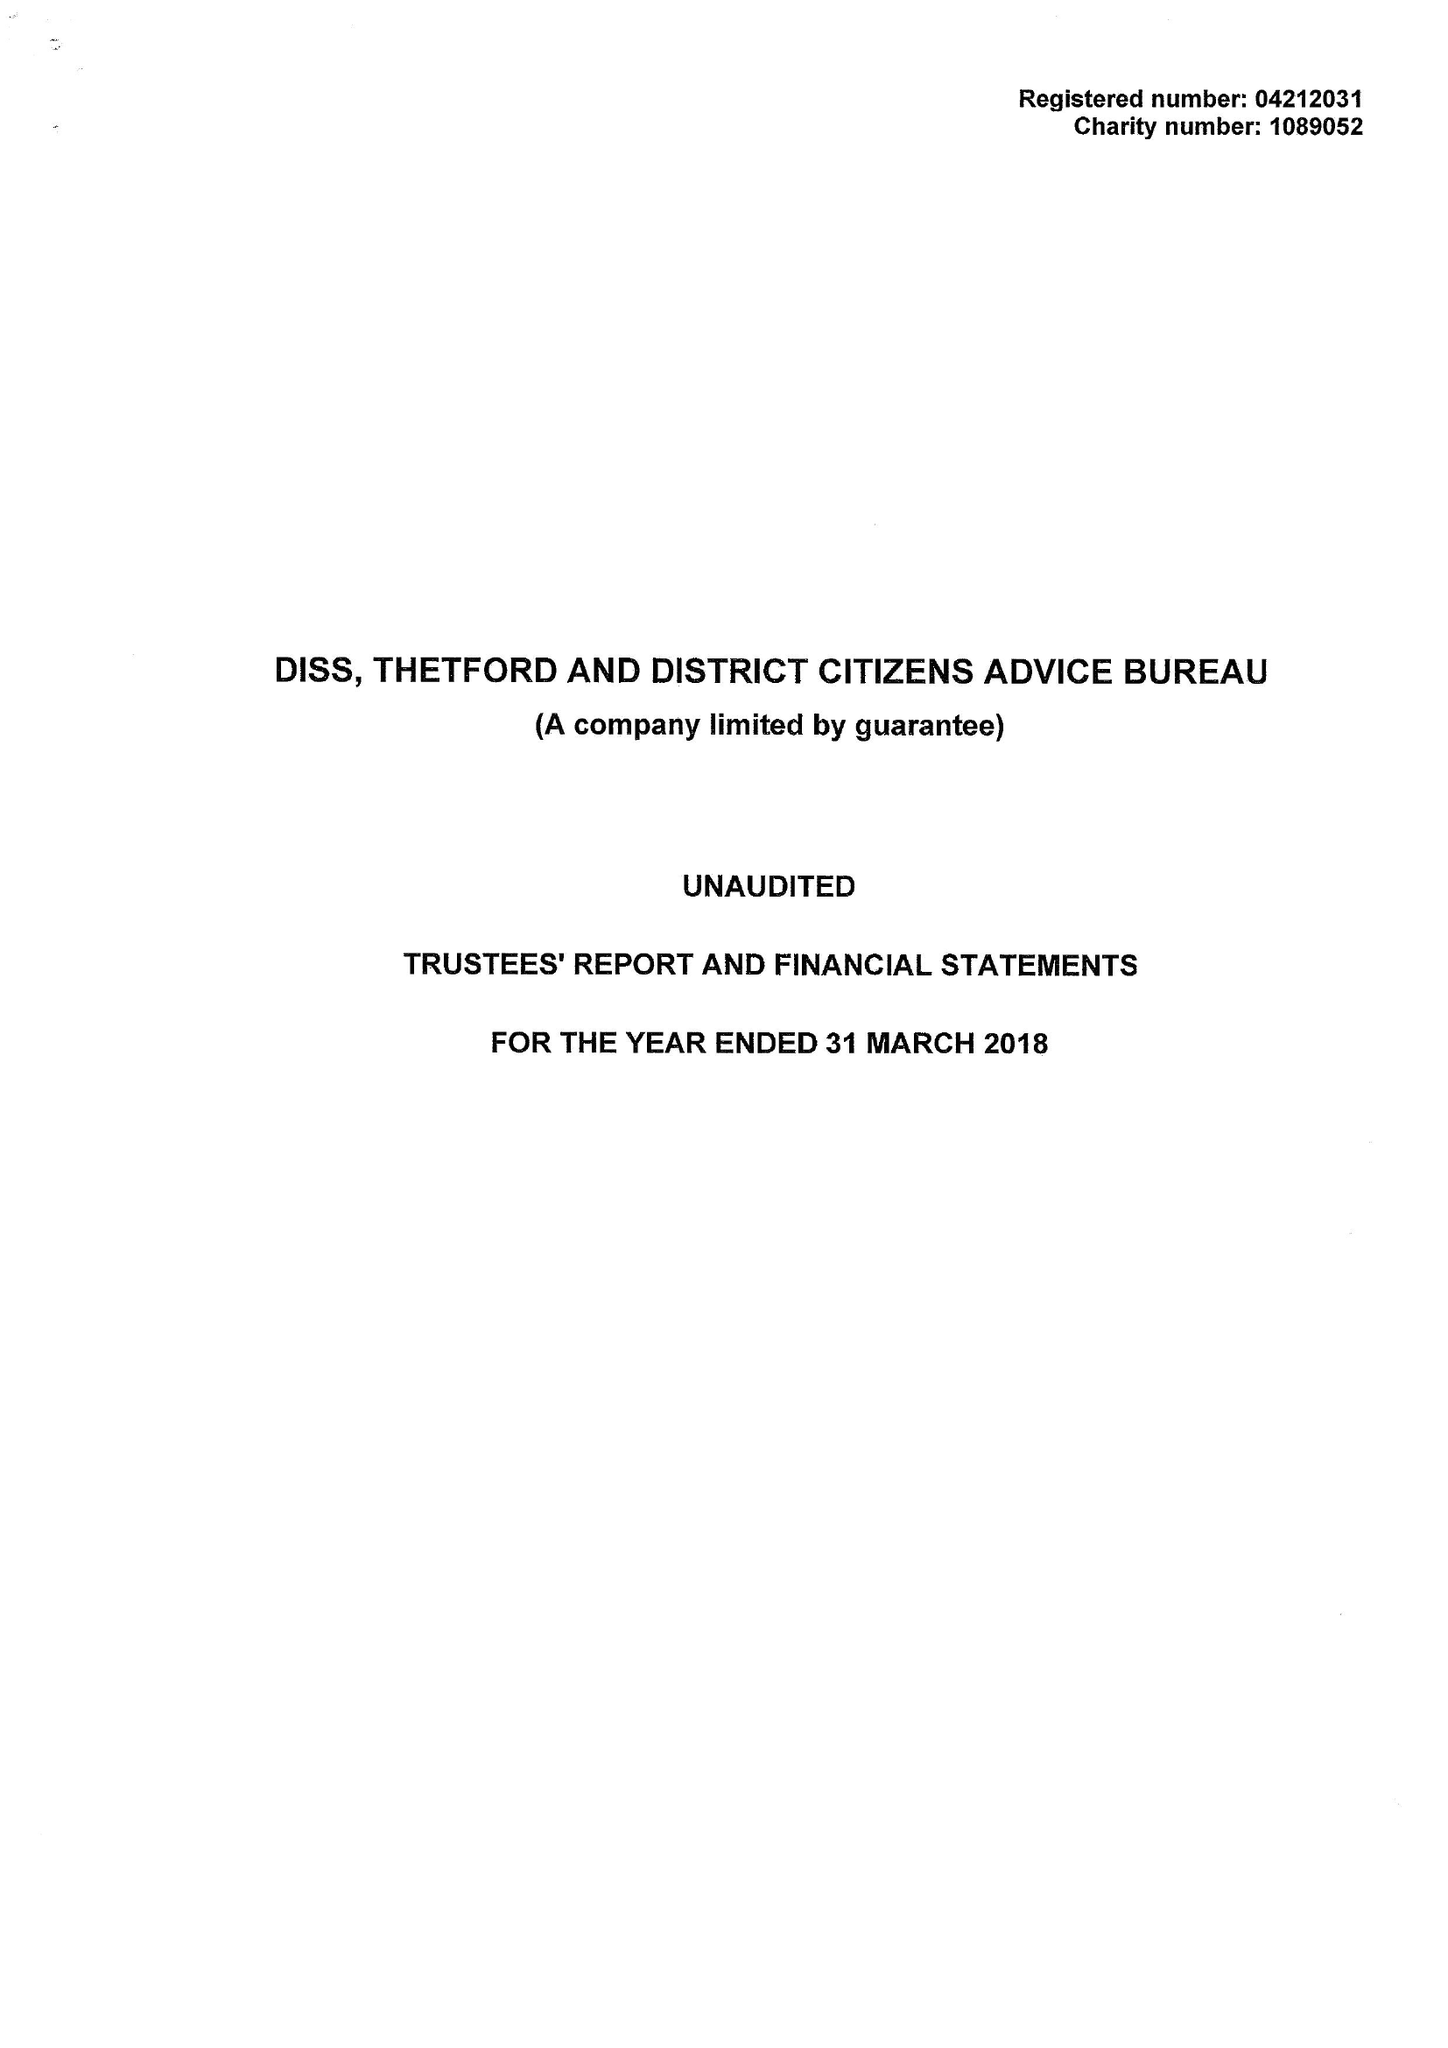What is the value for the charity_number?
Answer the question using a single word or phrase. 1089052 